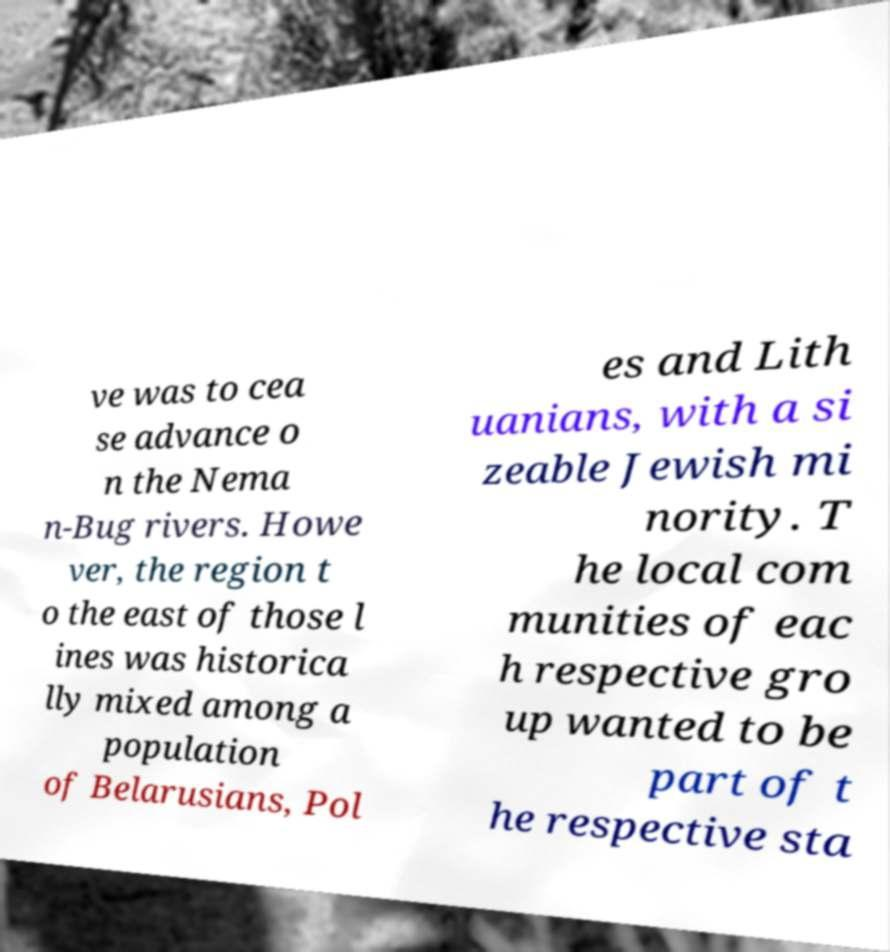Can you read and provide the text displayed in the image?This photo seems to have some interesting text. Can you extract and type it out for me? ve was to cea se advance o n the Nema n-Bug rivers. Howe ver, the region t o the east of those l ines was historica lly mixed among a population of Belarusians, Pol es and Lith uanians, with a si zeable Jewish mi nority. T he local com munities of eac h respective gro up wanted to be part of t he respective sta 